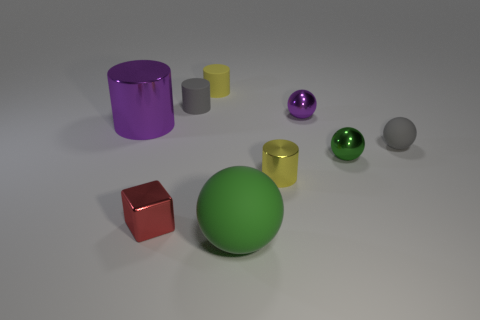What shape is the large object that is behind the tiny yellow thing that is in front of the purple metallic object that is left of the small cube?
Offer a terse response. Cylinder. How big is the metal cylinder behind the gray sphere?
Provide a short and direct response. Large. What is the shape of the red shiny thing that is the same size as the purple sphere?
Give a very brief answer. Cube. What number of objects are balls or things behind the tiny gray cylinder?
Keep it short and to the point. 5. What number of shiny cylinders are in front of the gray matte object that is on the right side of the tiny gray rubber object that is behind the gray ball?
Offer a very short reply. 1. What is the color of the big thing that is made of the same material as the red cube?
Keep it short and to the point. Purple. Does the purple metal thing on the left side of the green rubber sphere have the same size as the big sphere?
Provide a short and direct response. Yes. What number of objects are either tiny cyan spheres or matte cylinders?
Keep it short and to the point. 2. There is a small yellow cylinder that is to the right of the yellow cylinder behind the yellow cylinder that is in front of the purple metallic sphere; what is its material?
Keep it short and to the point. Metal. What is the tiny thing behind the small gray cylinder made of?
Your answer should be compact. Rubber. 